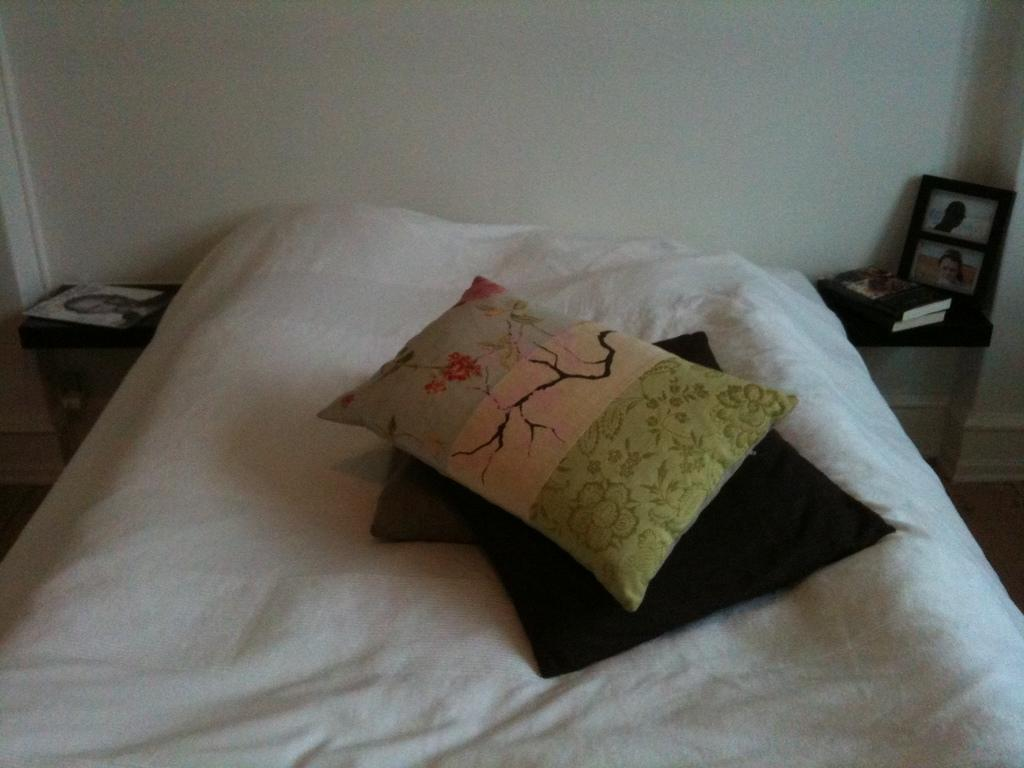What objects are on the bed in the image? There are pillows on the bed. What is on the table in the image? There is a poster, books, and a frame on the table. What can be seen in the background of the image? There is a wall visible in the background of the image. How many bananas are hanging from the wall in the image? There are no bananas present in the image; the wall is visible in the background, but no bananas are hanging from it. 